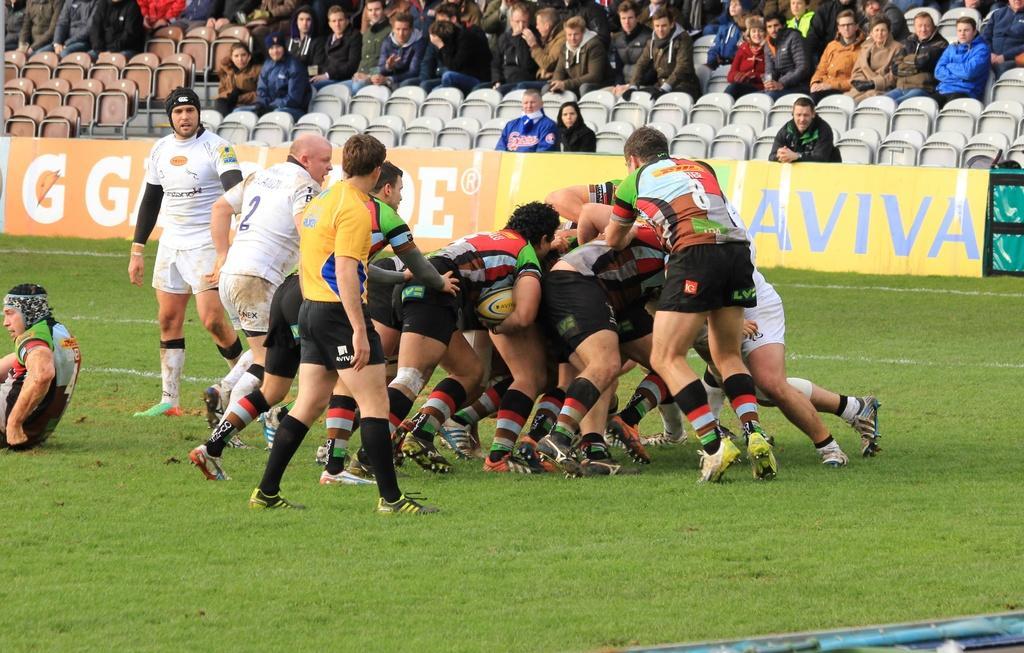In one or two sentences, can you explain what this image depicts? In this image few persons are playing on the grass land. Few persons are walking on the grassland. Left side a person is sitting on the grassland. Top of the image few persons are sitting on the chairs. Before them there is a banner. 